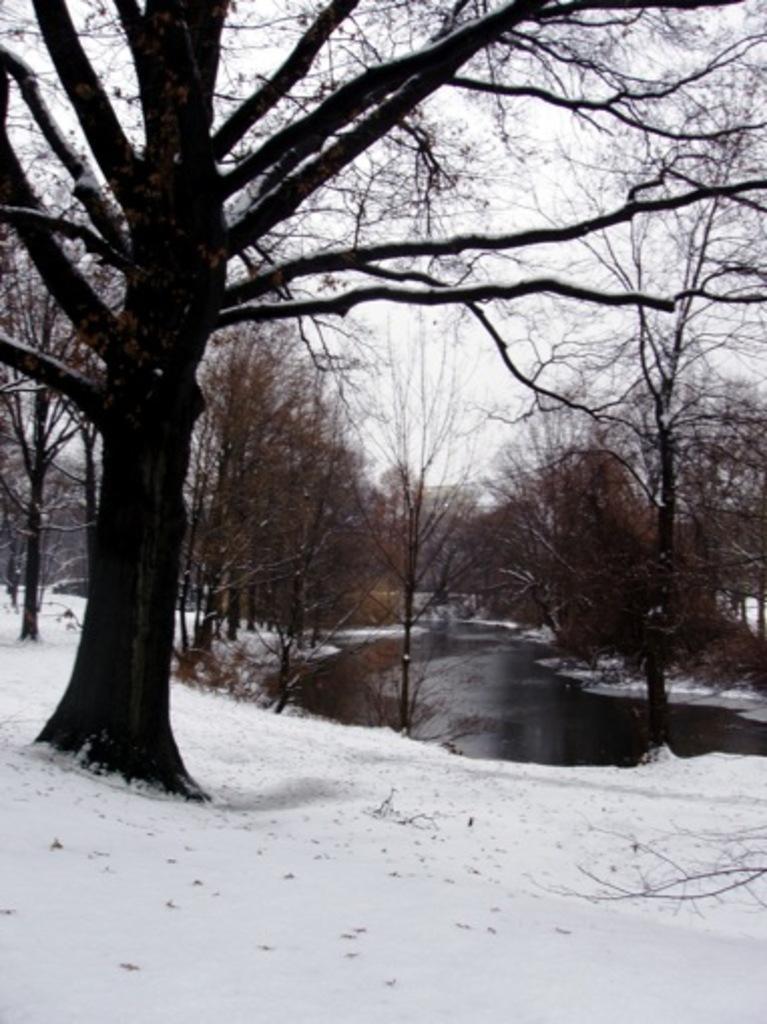Could you give a brief overview of what you see in this image? In the foreground of this picture, there is a tree. In the background, there is a river, snow and the sky. 